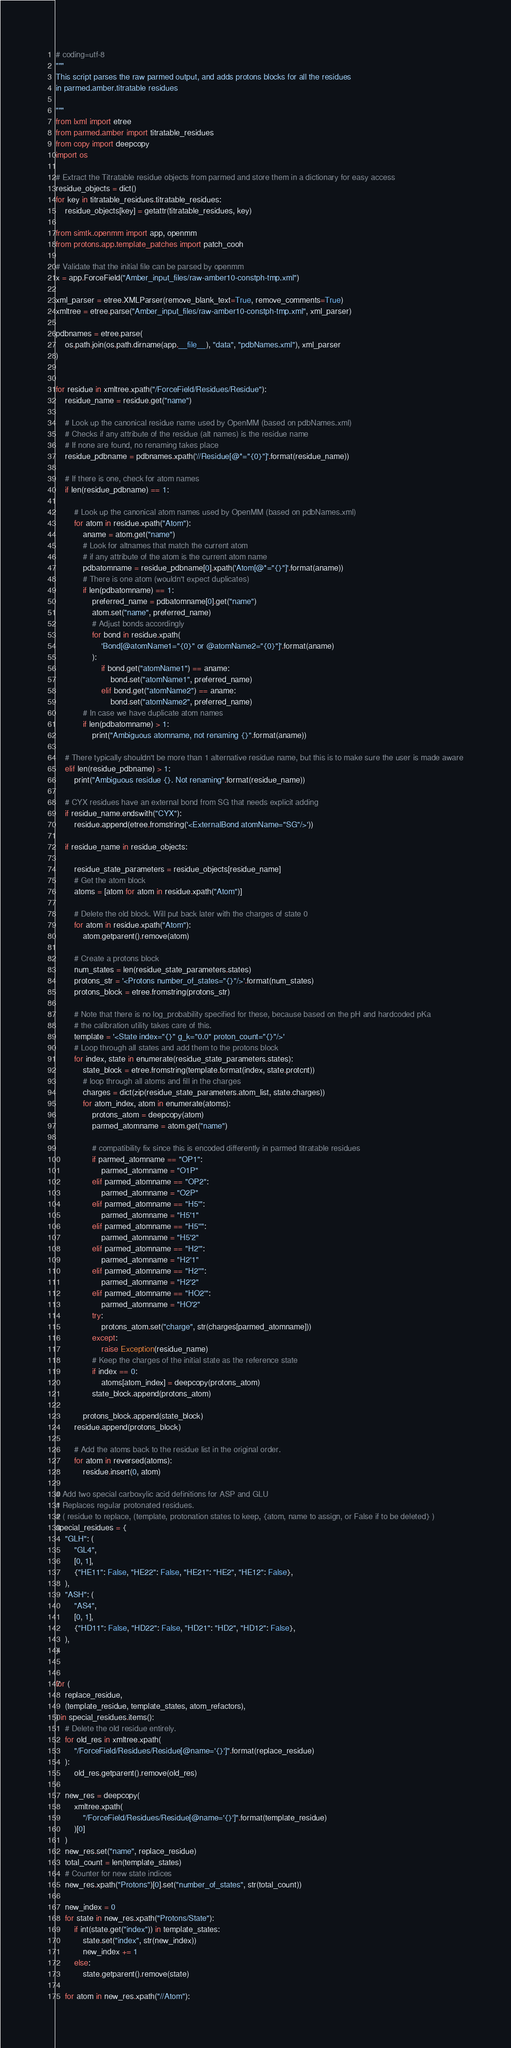Convert code to text. <code><loc_0><loc_0><loc_500><loc_500><_Python_># coding=utf-8
"""
This script parses the raw parmed output, and adds protons blocks for all the residues
in parmed.amber.titratable residues

"""
from lxml import etree
from parmed.amber import titratable_residues
from copy import deepcopy
import os

# Extract the Titratable residue objects from parmed and store them in a dictionary for easy access
residue_objects = dict()
for key in titratable_residues.titratable_residues:
    residue_objects[key] = getattr(titratable_residues, key)

from simtk.openmm import app, openmm
from protons.app.template_patches import patch_cooh

# Validate that the initial file can be parsed by openmm
x = app.ForceField("Amber_input_files/raw-amber10-constph-tmp.xml")

xml_parser = etree.XMLParser(remove_blank_text=True, remove_comments=True)
xmltree = etree.parse("Amber_input_files/raw-amber10-constph-tmp.xml", xml_parser)

pdbnames = etree.parse(
    os.path.join(os.path.dirname(app.__file__), "data", "pdbNames.xml"), xml_parser
)


for residue in xmltree.xpath("/ForceField/Residues/Residue"):
    residue_name = residue.get("name")

    # Look up the canonical residue name used by OpenMM (based on pdbNames.xml)
    # Checks if any attribute of the residue (alt names) is the residue name
    # If none are found, no renaming takes place
    residue_pdbname = pdbnames.xpath('//Residue[@*="{0}"]'.format(residue_name))

    # If there is one, check for atom names
    if len(residue_pdbname) == 1:

        # Look up the canonical atom names used by OpenMM (based on pdbNames.xml)
        for atom in residue.xpath("Atom"):
            aname = atom.get("name")
            # Look for altnames that match the current atom
            # if any attribute of the atom is the current atom name
            pdbatomname = residue_pdbname[0].xpath('Atom[@*="{}"]'.format(aname))
            # There is one atom (wouldn't expect duplicates)
            if len(pdbatomname) == 1:
                preferred_name = pdbatomname[0].get("name")
                atom.set("name", preferred_name)
                # Adjust bonds accordingly
                for bond in residue.xpath(
                    'Bond[@atomName1="{0}" or @atomName2="{0}"]'.format(aname)
                ):
                    if bond.get("atomName1") == aname:
                        bond.set("atomName1", preferred_name)
                    elif bond.get("atomName2") == aname:
                        bond.set("atomName2", preferred_name)
            # In case we have duplicate atom names
            if len(pdbatomname) > 1:
                print("Ambiguous atomname, not renaming {}".format(aname))

    # There typically shouldn't be more than 1 alternative residue name, but this is to make sure the user is made aware
    elif len(residue_pdbname) > 1:
        print("Ambiguous residue {}. Not renaming".format(residue_name))

    # CYX residues have an external bond from SG that needs explicit adding
    if residue_name.endswith("CYX"):
        residue.append(etree.fromstring('<ExternalBond atomName="SG"/>'))

    if residue_name in residue_objects:

        residue_state_parameters = residue_objects[residue_name]
        # Get the atom block
        atoms = [atom for atom in residue.xpath("Atom")]

        # Delete the old block. Will put back later with the charges of state 0
        for atom in residue.xpath("Atom"):
            atom.getparent().remove(atom)

        # Create a protons block
        num_states = len(residue_state_parameters.states)
        protons_str = '<Protons number_of_states="{}"/>'.format(num_states)
        protons_block = etree.fromstring(protons_str)

        # Note that there is no log_probability specified for these, because based on the pH and hardcoded pKa
        # the calibration utility takes care of this.
        template = '<State index="{}" g_k="0.0" proton_count="{}"/>'
        # Loop through all states and add them to the protons block
        for index, state in enumerate(residue_state_parameters.states):
            state_block = etree.fromstring(template.format(index, state.protcnt))
            # loop through all atoms and fill in the charges
            charges = dict(zip(residue_state_parameters.atom_list, state.charges))
            for atom_index, atom in enumerate(atoms):
                protons_atom = deepcopy(atom)
                parmed_atomname = atom.get("name")

                # compatibility fix since this is encoded differently in parmed titratable residues
                if parmed_atomname == "OP1":
                    parmed_atomname = "O1P"
                elif parmed_atomname == "OP2":
                    parmed_atomname = "O2P"
                elif parmed_atomname == "H5'":
                    parmed_atomname = "H5'1"
                elif parmed_atomname == "H5''":
                    parmed_atomname = "H5'2"
                elif parmed_atomname == "H2'":
                    parmed_atomname = "H2'1"
                elif parmed_atomname == "H2''":
                    parmed_atomname = "H2'2"
                elif parmed_atomname == "HO2'":
                    parmed_atomname = "HO'2"
                try:
                    protons_atom.set("charge", str(charges[parmed_atomname]))
                except:
                    raise Exception(residue_name)
                # Keep the charges of the initial state as the reference state
                if index == 0:
                    atoms[atom_index] = deepcopy(protons_atom)
                state_block.append(protons_atom)

            protons_block.append(state_block)
        residue.append(protons_block)

        # Add the atoms back to the residue list in the original order.
        for atom in reversed(atoms):
            residue.insert(0, atom)

# Add two special carboxylic acid definitions for ASP and GLU
# Replaces regular protonated residues.
# ( residue to replace, (template, protonation states to keep, {atom, name to assign, or False if to be deleted} )
special_residues = {
    "GLH": (
        "GL4",
        [0, 1],
        {"HE11": False, "HE22": False, "HE21": "HE2", "HE12": False},
    ),
    "ASH": (
        "AS4",
        [0, 1],
        {"HD11": False, "HD22": False, "HD21": "HD2", "HD12": False},
    ),
}


for (
    replace_residue,
    (template_residue, template_states, atom_refactors),
) in special_residues.items():
    # Delete the old residue entirely.
    for old_res in xmltree.xpath(
        "/ForceField/Residues/Residue[@name='{}']".format(replace_residue)
    ):
        old_res.getparent().remove(old_res)

    new_res = deepcopy(
        xmltree.xpath(
            "/ForceField/Residues/Residue[@name='{}']".format(template_residue)
        )[0]
    )
    new_res.set("name", replace_residue)
    total_count = len(template_states)
    # Counter for new state indices
    new_res.xpath("Protons")[0].set("number_of_states", str(total_count))

    new_index = 0
    for state in new_res.xpath("Protons/State"):
        if int(state.get("index")) in template_states:
            state.set("index", str(new_index))
            new_index += 1
        else:
            state.getparent().remove(state)

    for atom in new_res.xpath("//Atom"):</code> 